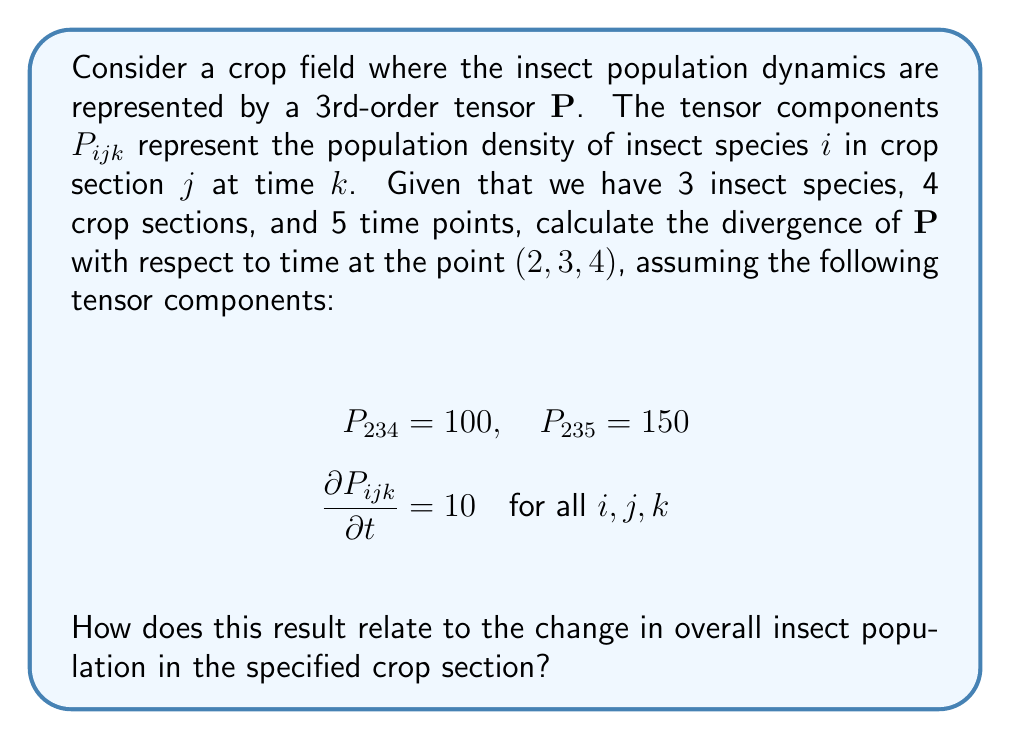What is the answer to this math problem? To solve this problem, we need to follow these steps:

1) First, recall that the divergence of a 3rd-order tensor $\mathbf{P}$ with respect to time is given by:

   $$\nabla_t \cdot \mathbf{P} = \sum_{i=1}^3 \frac{\partial P_{i34}}{\partial t}$$

   Here, we're calculating the divergence at the point (2,3,4), so we fix $j=3$ and $k=4$.

2) We're given that $\frac{\partial P_{ijk}}{\partial t} = 10$ for all $i,j,k$. This means:

   $$\frac{\partial P_{134}}{\partial t} = \frac{\partial P_{234}}{\partial t} = \frac{\partial P_{334}}{\partial t} = 10$$

3) Now, we can calculate the divergence:

   $$\nabla_t \cdot \mathbf{P} = \sum_{i=1}^3 \frac{\partial P_{i34}}{\partial t} = 10 + 10 + 10 = 30$$

4) To interpret this result in terms of insect population dynamics:
   - The divergence represents the rate of change of the insect population density in crop section 3 at time point 4.
   - A positive divergence (30) indicates that the overall insect population in this crop section is increasing over time.
   - The value 30 means that the total population density across all three insect species in crop section 3 is increasing at a rate of 30 insects per unit time at time point 4.

5) We can verify this by looking at the given tensor components:
   $$P_{234} = 100, \quad P_{235} = 150$$
   This shows an increase of 50 in the population of insect species 2 in crop section 3 from time point 4 to 5, which is consistent with our calculated rate of change.
Answer: $$\nabla_t \cdot \mathbf{P} = 30$$, indicating an overall increase in insect population density. 